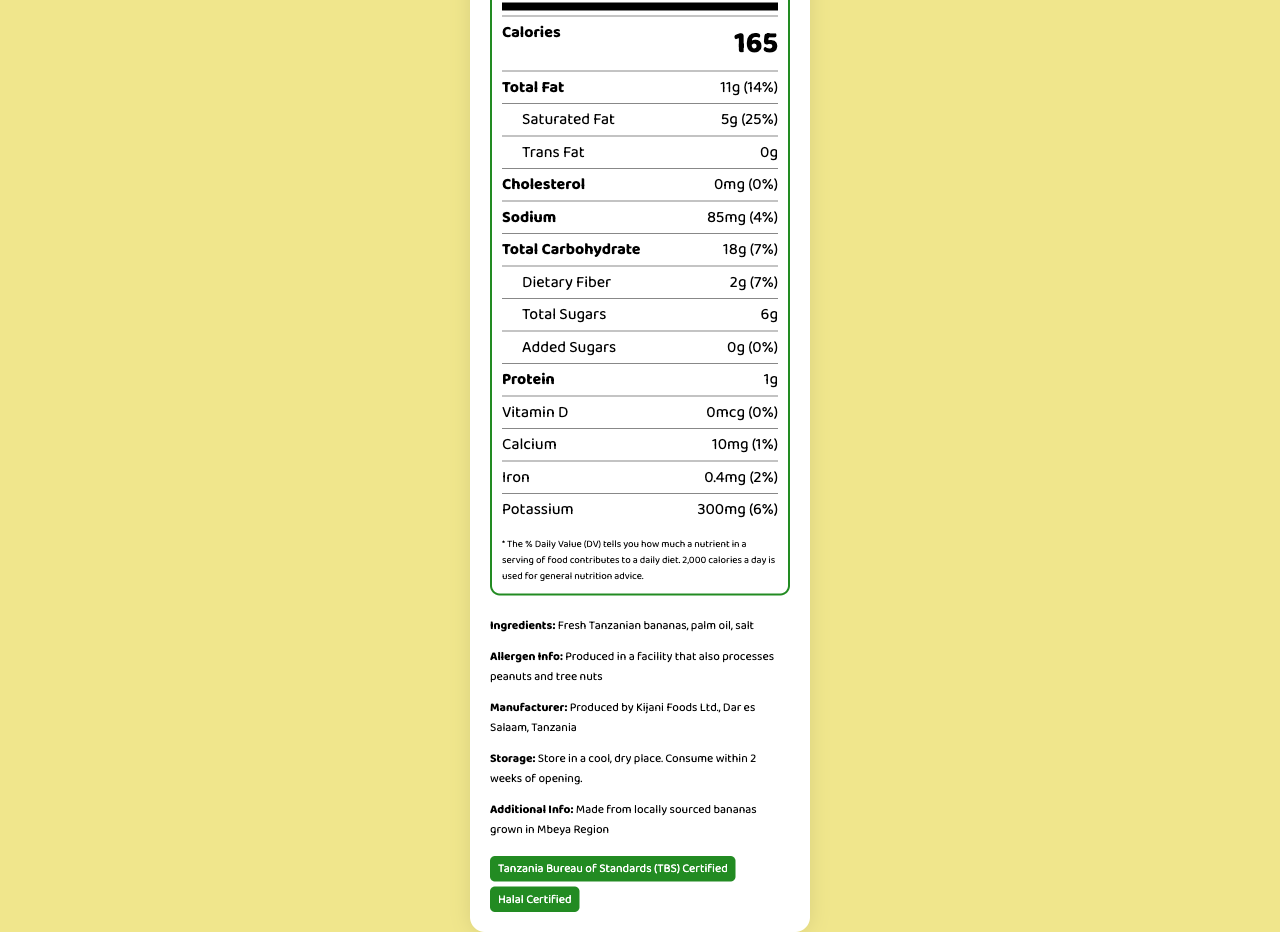What is the serving size of Kijani Chips? The serving size is clearly mentioned in the document as "30 grams (approximately 15 chips)".
Answer: 30 grams (approximately 15 chips) How many servings are there per container? The document states "4 servings per container".
Answer: 4 How many calories are in one serving? The calories per serving are listed as 165.
Answer: 165 What is the total amount of fat per serving? The document specifies "Total Fat" as "11g".
Answer: 11g What percentage of daily value is saturated fat? The document mentions "Saturated Fat" as "25%".
Answer: 25% How much sodium is in a serving? A. 50mg B. 85mg C. 100mg D. 120mg The amount of sodium per serving is listed as 85mg.
Answer: B What is the amount of dietary fiber per serving? A. 1g B. 2g C. 3g D. 4g The amount of dietary fiber is listed as 2g in the document.
Answer: B Is the product Halal certified? The document mentions that the product is "Halal Certified".
Answer: Yes Does Kijani Chips contain any added sugars? The document states "Added Sugars" as "0g".
Answer: No Can we determine where the bananas are sourced from? The document mentions that the bananas are "locally sourced bananas grown in Mbeya Region".
Answer: Yes How should Kijani Chips be stored after opening? The document specifies the storage instructions as "Store in a cool, dry place. Consume within 2 weeks of opening".
Answer: Store in a cool, dry place. Consume within 2 weeks of opening. Does Kijani Chips contain trans fat? The document states "Trans Fat" as "0g".
Answer: No How much protein is in one serving of Kijani Chips? The document lists protein content as 1g per serving.
Answer: 1g What additional certifications does Kijani Chips have apart from Halal? The document states that the product is "Tanzania Bureau of Standards (TBS) Certified" in addition to being Halal Certified.
Answer: Tanzania Bureau of Standards (TBS) Certified Describe the main information provided in the document. The main idea of the document is to inform consumers about the nutritional content, ingredients, and certifications of Kijani Chips, ensuring they have essential information for making dietary decisions.
Answer: The document provides a detailed nutrition facts label for Kijani Chips, a locally produced banana chips product. It includes information about serving size, calories, macronutrient contents like fats, carbohydrates, and proteins, as well as micronutrient details such as vitamins and minerals. It also lists ingredients, allergen information, manufacturer details, storage instructions, and certifications. Who is the manufacturer of Kijani Chips? The document specifies that "Kijani Foods Ltd., Dar es Salaam, Tanzania" is the manufacturer.
Answer: Kijani Foods Ltd., Dar es Salaam, Tanzania What percentage of the daily value of calcium is in one serving? The document lists "Calcium" as "1%".
Answer: 1% What are the ingredients of Kijani Chips? The ingredients are listed clearly in the document as "Fresh Tanzanian bananas, palm oil, salt".
Answer: Fresh Tanzanian bananas, palm oil, salt Is there any information about whether the product contains peanuts? The allergen information in the document mentions "Produced in a facility that also processes peanuts and tree nuts".
Answer: Yes, it states the product is produced in a facility that also processes peanuts and tree nuts. 